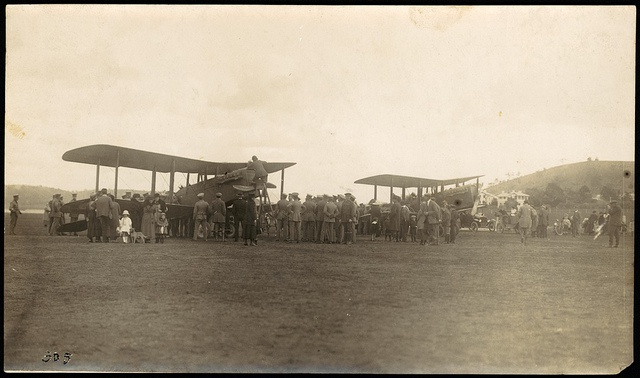Describe the objects in this image and their specific colors. I can see airplane in black, gray, and beige tones, people in black, gray, and tan tones, people in black and gray tones, people in black and gray tones, and people in black and gray tones in this image. 